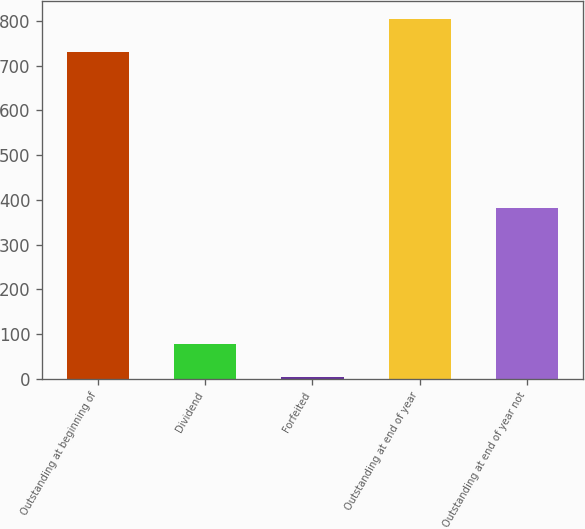Convert chart to OTSL. <chart><loc_0><loc_0><loc_500><loc_500><bar_chart><fcel>Outstanding at beginning of<fcel>Dividend<fcel>Forfeited<fcel>Outstanding at end of year<fcel>Outstanding at end of year not<nl><fcel>731<fcel>78.3<fcel>4<fcel>805.3<fcel>381<nl></chart> 